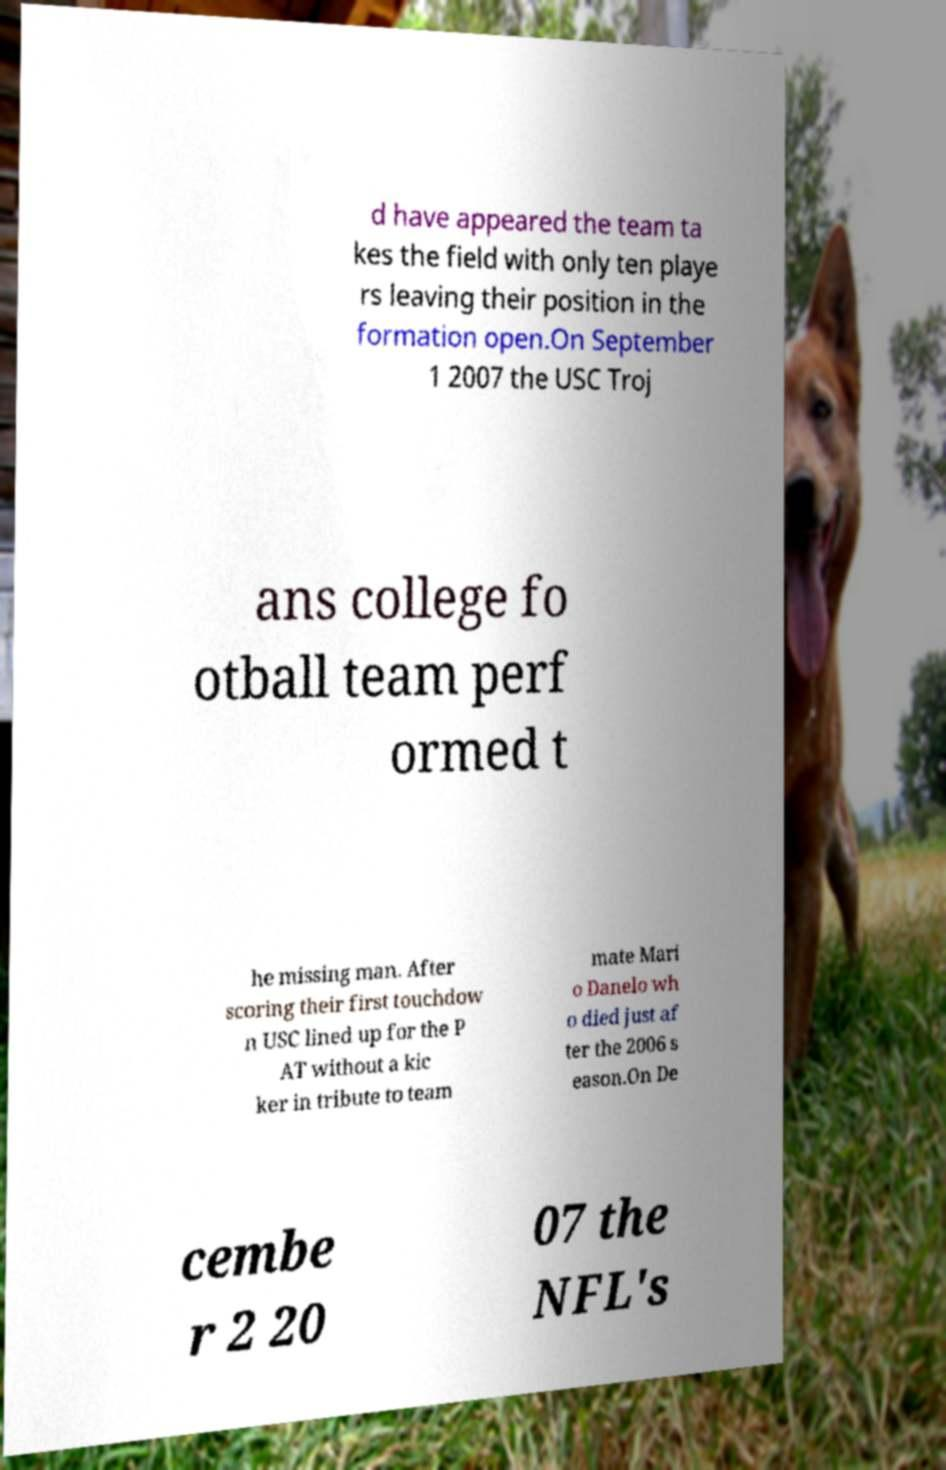Could you extract and type out the text from this image? d have appeared the team ta kes the field with only ten playe rs leaving their position in the formation open.On September 1 2007 the USC Troj ans college fo otball team perf ormed t he missing man. After scoring their first touchdow n USC lined up for the P AT without a kic ker in tribute to team mate Mari o Danelo wh o died just af ter the 2006 s eason.On De cembe r 2 20 07 the NFL's 